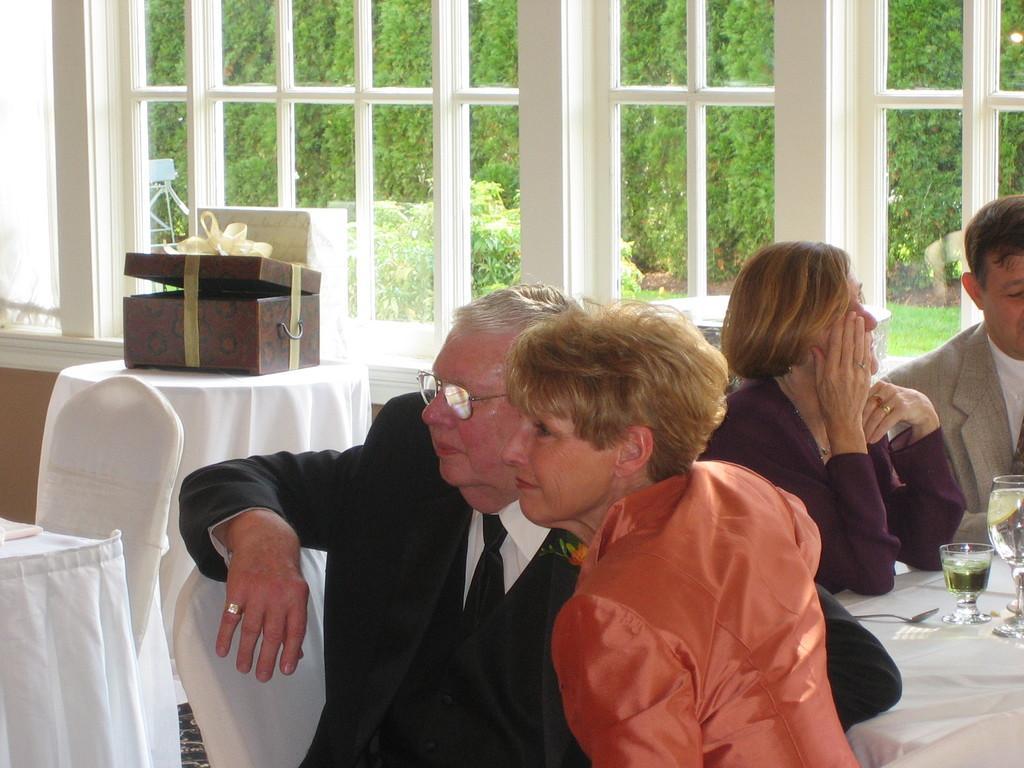How would you summarize this image in a sentence or two? In this image, there are two persons wearing clothes and sitting in front of this table. This table contains glasses and spoon. There is an another table which covered with a cloth and contains a box. This person is sitting in a chair and wearing spectacles on his head. There are some trees behind this window. 